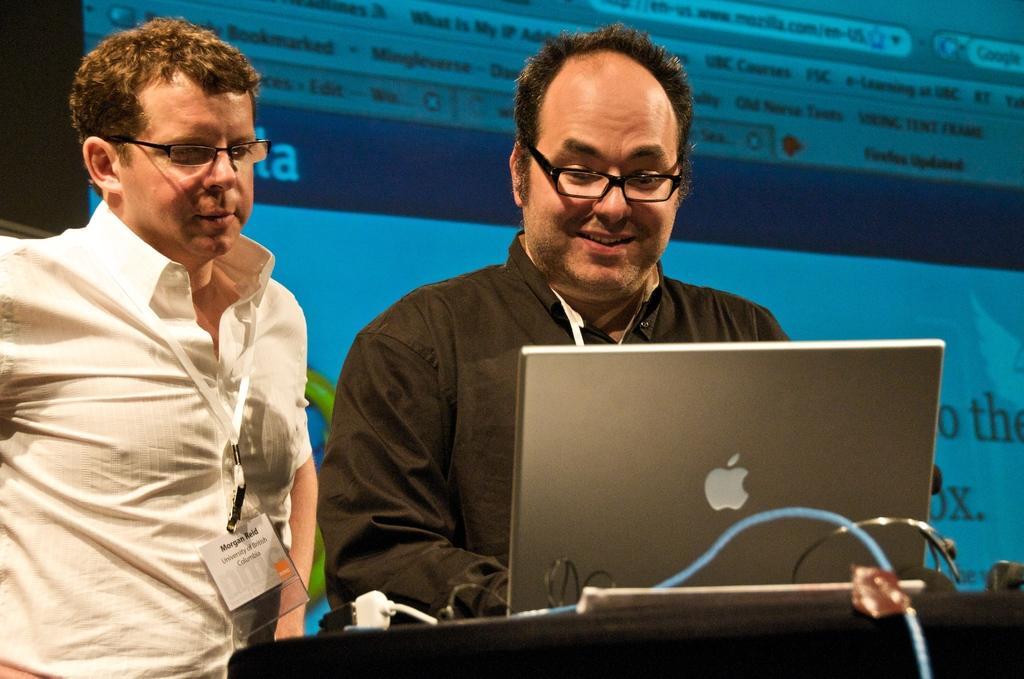In one or two sentences, can you explain what this image depicts? In this picture I can see there are two people standing here and they are wearing a white shirt and in the backdrop I can see there is a screen. 